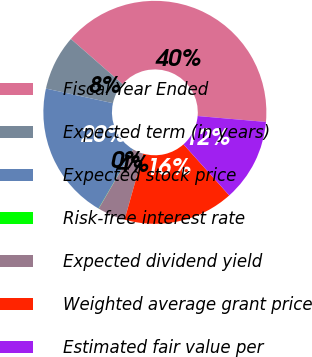Convert chart. <chart><loc_0><loc_0><loc_500><loc_500><pie_chart><fcel>Fiscal Year Ended<fcel>Expected term (in years)<fcel>Expected stock price<fcel>Risk-free interest rate<fcel>Expected dividend yield<fcel>Weighted average grant price<fcel>Estimated fair value per<nl><fcel>39.94%<fcel>8.01%<fcel>19.99%<fcel>0.03%<fcel>4.02%<fcel>16.0%<fcel>12.01%<nl></chart> 